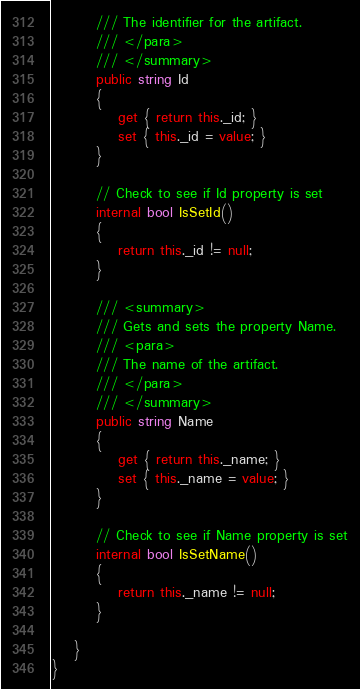Convert code to text. <code><loc_0><loc_0><loc_500><loc_500><_C#_>        /// The identifier for the artifact.
        /// </para>
        /// </summary>
        public string Id
        {
            get { return this._id; }
            set { this._id = value; }
        }

        // Check to see if Id property is set
        internal bool IsSetId()
        {
            return this._id != null;
        }

        /// <summary>
        /// Gets and sets the property Name. 
        /// <para>
        /// The name of the artifact.
        /// </para>
        /// </summary>
        public string Name
        {
            get { return this._name; }
            set { this._name = value; }
        }

        // Check to see if Name property is set
        internal bool IsSetName()
        {
            return this._name != null;
        }

    }
}</code> 